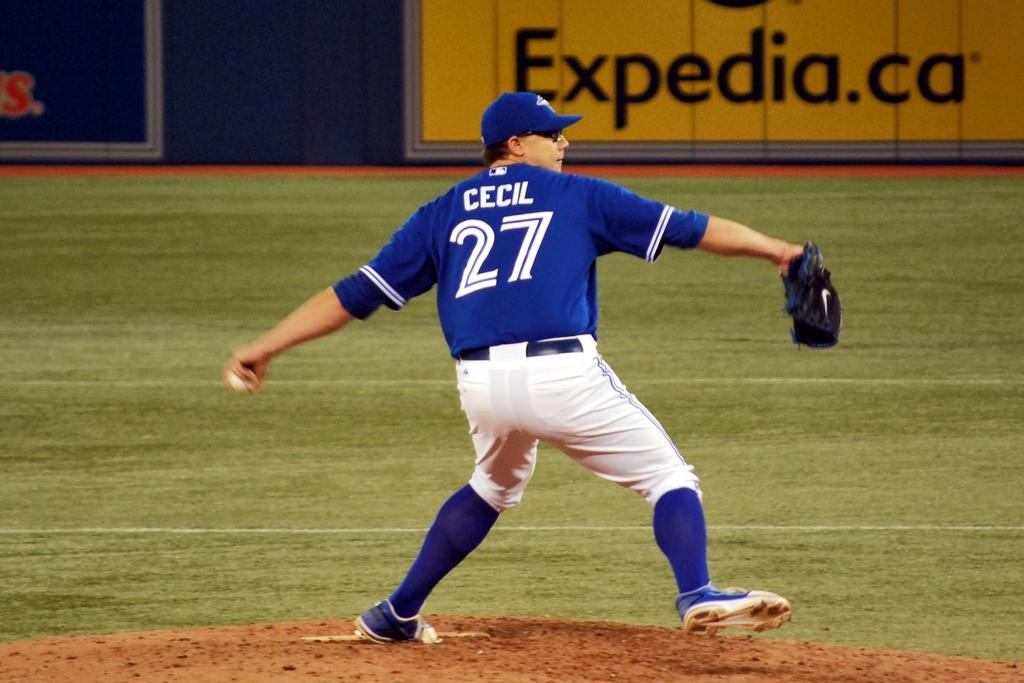What is the name of the pitcher?
Offer a very short reply. Cecil. What number is the player wearing?
Your answer should be compact. 27. 